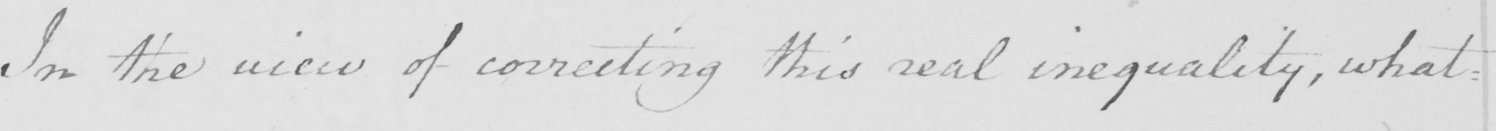Can you tell me what this handwritten text says? In the view of correcting this real inequality , what : 